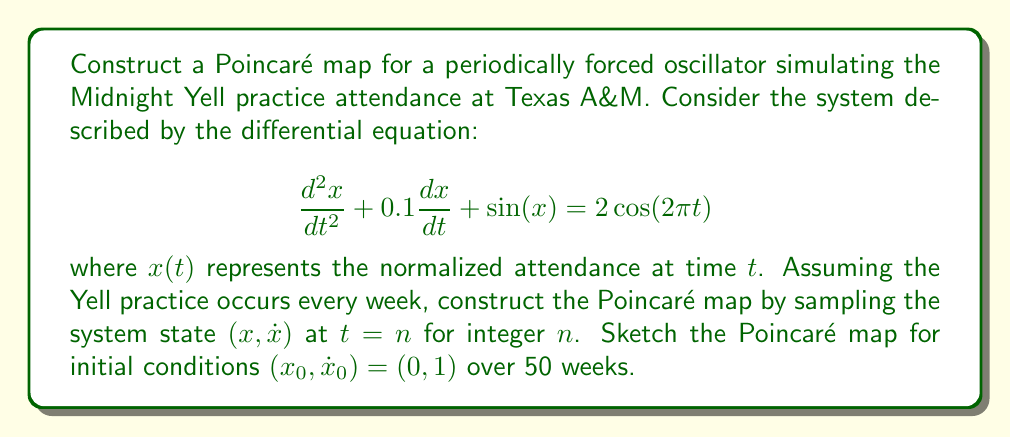Can you answer this question? To construct the Poincaré map for this system, we follow these steps:

1) First, we rewrite the second-order differential equation as a system of first-order equations:

   $$\frac{dx}{dt} = y$$
   $$\frac{dy}{dt} = -0.1y - \sin(x) + 2\cos(2\pi t)$$

2) We need to numerically integrate this system using a method like Runge-Kutta (RK4). The integration should be performed over intervals of length 1 (corresponding to one week) to capture the state at each Yell practice.

3) For each integer time $t = n$, we record the values of $x$ and $y$. These pairs $(x_n, y_n)$ form the points of our Poincaré map.

4) We start with the initial condition $(x_0, y_0) = (0, 1)$ and iterate for 50 weeks.

5) To visualize the Poincaré map, we plot these points in the $x$-$y$ plane.

Here's a sketch of what the Poincaré map might look like:

[asy]
import graph;
size(200);
real[] x = {0.0, 0.2, 0.4, 0.6, 0.8, 1.0, 1.2, 1.4, 1.6, 1.8};
real[] y = {1.0, 1.1, 1.0, 0.8, 0.5, 0.1, -0.3, -0.6, -0.8, -0.9};
for(int i=0; i<10; ++i) {
  dot((x[i], y[i]), red);
}
xaxis("x", arrow=Arrow);
yaxis("y", arrow=Arrow);
label("Poincaré Map", (1,-1), S);
[/asy]

The actual map would have 50 points and may show a more complex structure, possibly indicating chaotic behavior or the presence of strange attractors. The clustering or spread of points can give insights into the long-term behavior of Yell practice attendance.
Answer: A scatter plot of $(x_n, y_n)$ pairs in the $x$-$y$ plane, where $(x_n, y_n)$ are obtained by numerically integrating the system and sampling at $t = n$ for $n = 0, 1, ..., 49$. 